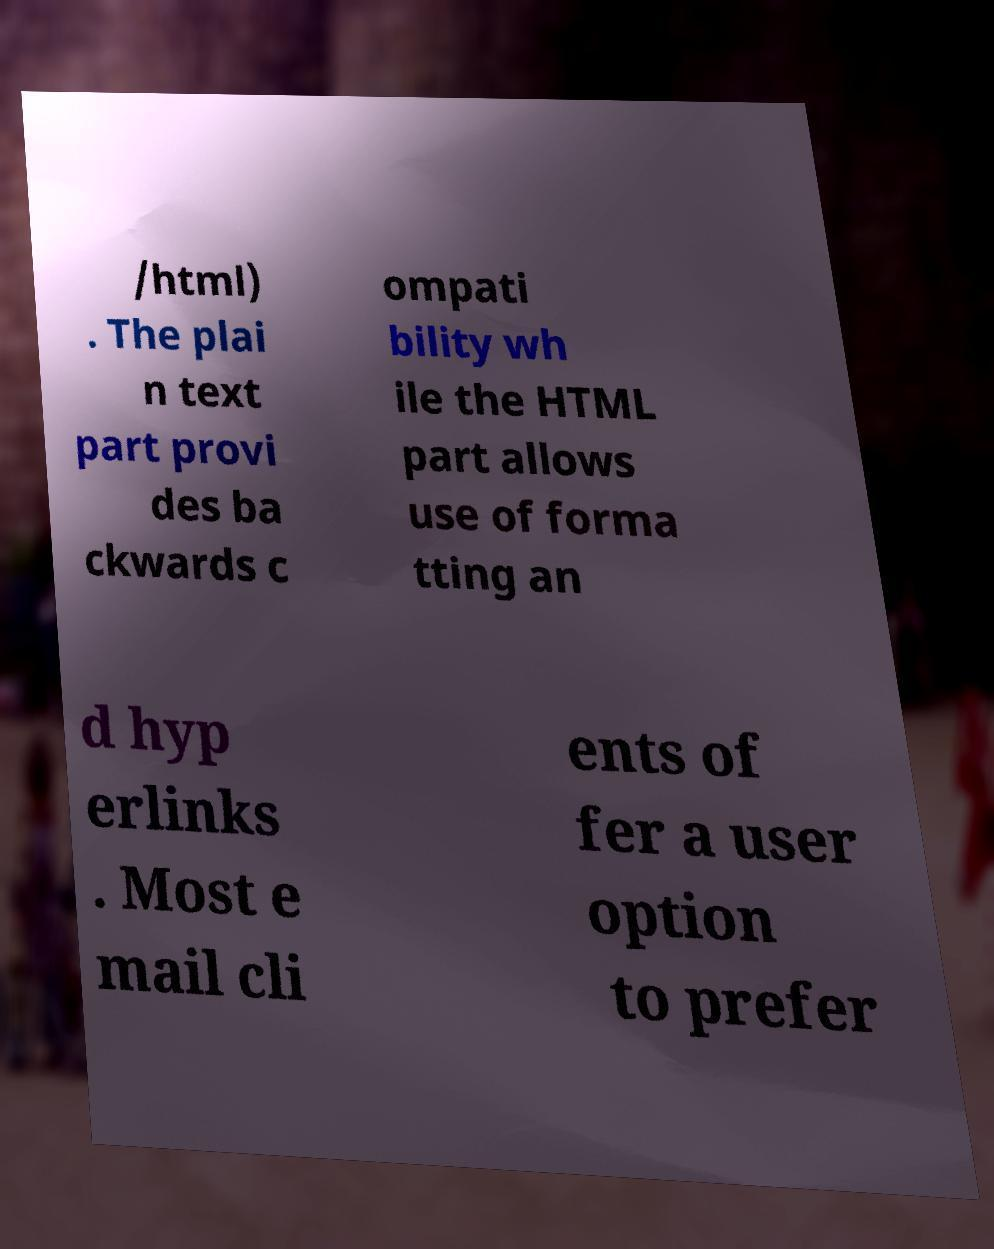Please read and relay the text visible in this image. What does it say? /html) . The plai n text part provi des ba ckwards c ompati bility wh ile the HTML part allows use of forma tting an d hyp erlinks . Most e mail cli ents of fer a user option to prefer 